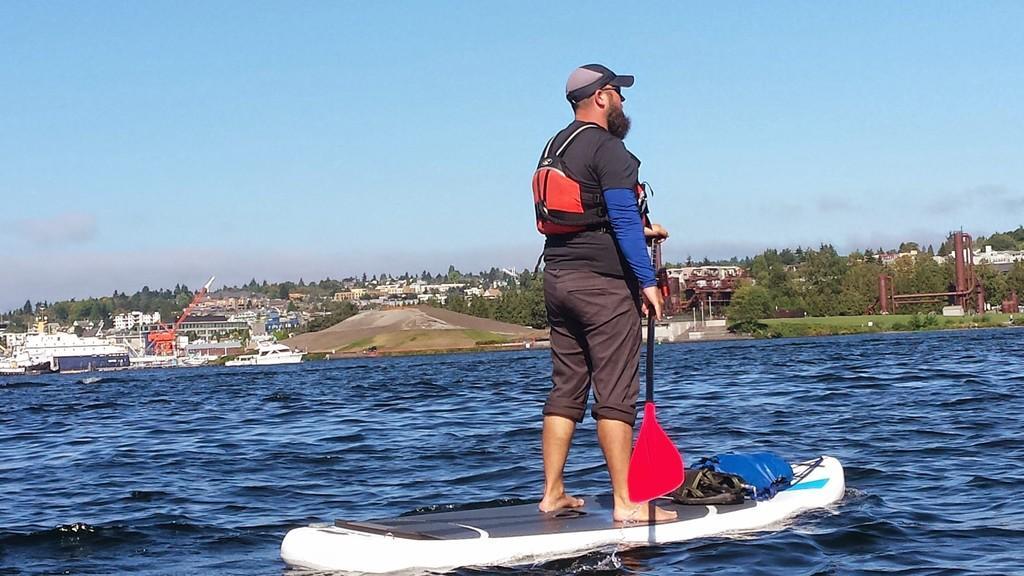How would you summarize this image in a sentence or two? In this picture there is a man who is wearing cap, t-shirt, bag, trouser and holding a stick. He is standing on the skateboard, beside him i can see the water. In the background i can see the crane, many buildings, trees, poles and mountain. On the left i can see the sky and clouds. Near to the beach there is a boat. 